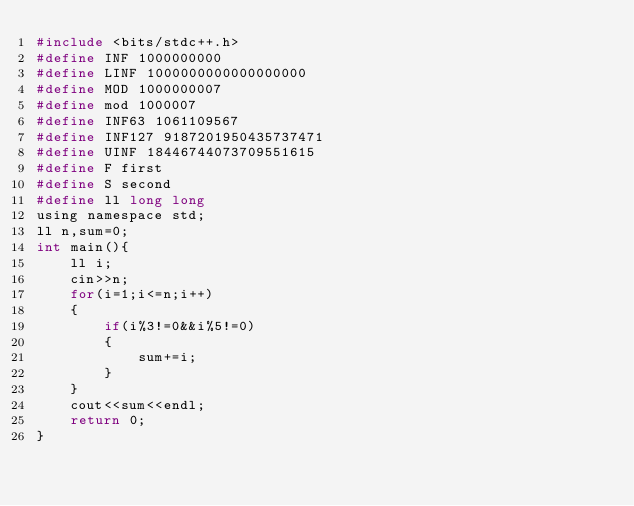Convert code to text. <code><loc_0><loc_0><loc_500><loc_500><_C_>#include <bits/stdc++.h>
#define INF 1000000000
#define LINF 1000000000000000000
#define MOD 1000000007
#define mod 1000007
#define INF63 1061109567
#define INF127 9187201950435737471
#define UINF 18446744073709551615
#define F first
#define S second
#define ll long long
using namespace std;
ll n,sum=0;
int main(){
	ll i;
	cin>>n;
	for(i=1;i<=n;i++)
	{
		if(i%3!=0&&i%5!=0)
		{
			sum+=i;
		}
	}
	cout<<sum<<endl;
	return 0;
}</code> 